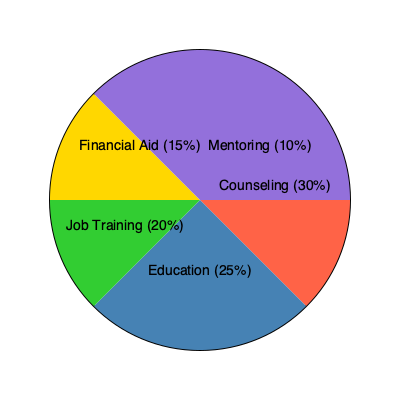Based on the pie chart showing resource allocation for family support programs, which two areas combined account for more than half of the total resources? Explain how this allocation might impact the effectiveness of support for families affected by incarceration. To answer this question, we need to analyze the pie chart and consider the implications of resource allocation:

1. Identify the two largest segments:
   - Counseling: 30%
   - Education: 25%

2. Calculate the combined percentage:
   $30\% + 25\% = 55\%$

3. Confirm that this is indeed more than half (50%) of the total resources.

4. Consider the impact on families affected by incarceration:

   a) Counseling (30%):
      - Helps address emotional and psychological challenges
      - Supports family members in coping with separation and stigma
      - Aids in maintaining family bonds despite incarceration

   b) Education (25%):
      - Provides skills and knowledge for both children and adults
      - Improves long-term prospects for employment and social mobility
      - Helps break the cycle of intergenerational incarceration

5. Potential effectiveness:
   - The focus on counseling and education (55% combined) suggests a strong emphasis on addressing both immediate emotional needs and long-term socioeconomic factors.
   - This allocation may be particularly effective for families affected by incarceration as it targets both the psychological impact of having a family member in prison and the educational barriers that often contribute to cycles of poverty and crime.
   - However, the lower allocation to areas like job training (20%) and financial aid (15%) might limit immediate economic support, which could be crucial for families facing financial hardship due to incarceration.

6. Considerations for improvement:
   - The effectiveness could be enhanced by ensuring strong integration between these programs, especially linking counseling and education to job training opportunities.
   - The relatively small allocation to mentoring (10%) might be a limitation, as mentoring programs can be highly beneficial for children of incarcerated parents.
Answer: Counseling and Education (55% combined); this allocation addresses both immediate emotional needs and long-term socioeconomic factors, potentially breaking cycles of incarceration, but may limit immediate economic support. 